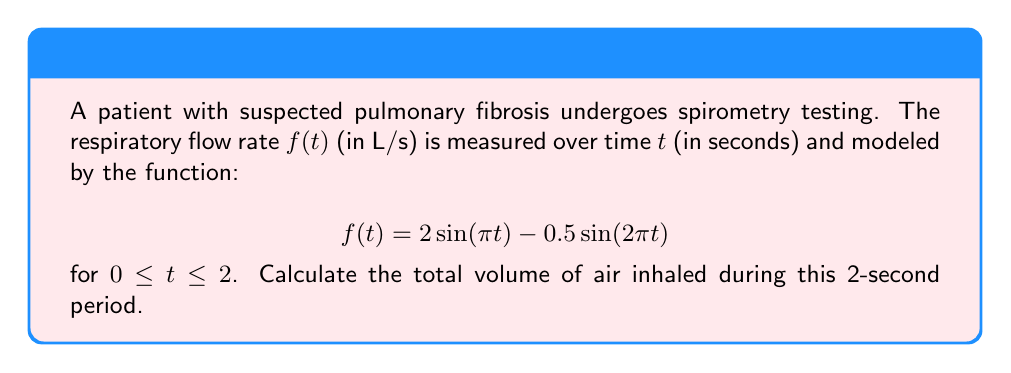Could you help me with this problem? To solve this inverse problem and determine the lung volume from respiratory flow measurements, we need to follow these steps:

1) The volume of air inhaled is the integral of the flow rate over time. Mathematically, this is expressed as:

   $$V = \int_0^2 f(t) dt$$

2) Substituting the given function:

   $$V = \int_0^2 (2\sin(\pi t) - 0.5\sin(2\pi t)) dt$$

3) We can solve this integral using the following antiderivative rules:
   
   $$\int \sin(ax) dx = -\frac{1}{a}\cos(ax) + C$$

4) Applying these rules:

   $$V = \left[-\frac{2}{\pi}\cos(\pi t) + \frac{0.5}{2\pi}\cos(2\pi t)\right]_0^2$$

5) Evaluating the integral:

   $$V = \left[-\frac{2}{\pi}\cos(2\pi) + \frac{0.5}{2\pi}\cos(4\pi)\right] - \left[-\frac{2}{\pi}\cos(0) + \frac{0.5}{2\pi}\cos(0)\right]$$

6) Simplify, noting that $\cos(2\pi) = \cos(4\pi) = \cos(0) = 1$:

   $$V = \left[-\frac{2}{\pi} + \frac{0.5}{2\pi}\right] - \left[-\frac{2}{\pi} + \frac{0.5}{2\pi}\right] = 0$$

7) The result is zero because over a complete respiratory cycle, the volume inhaled equals the volume exhaled.
Answer: 0 L 